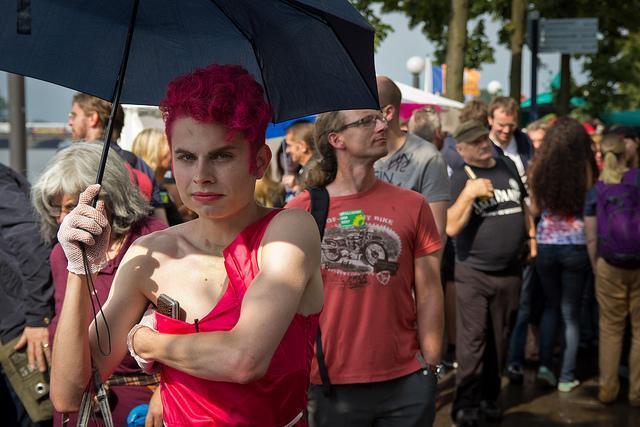How many people are visible?
Give a very brief answer. 11. 